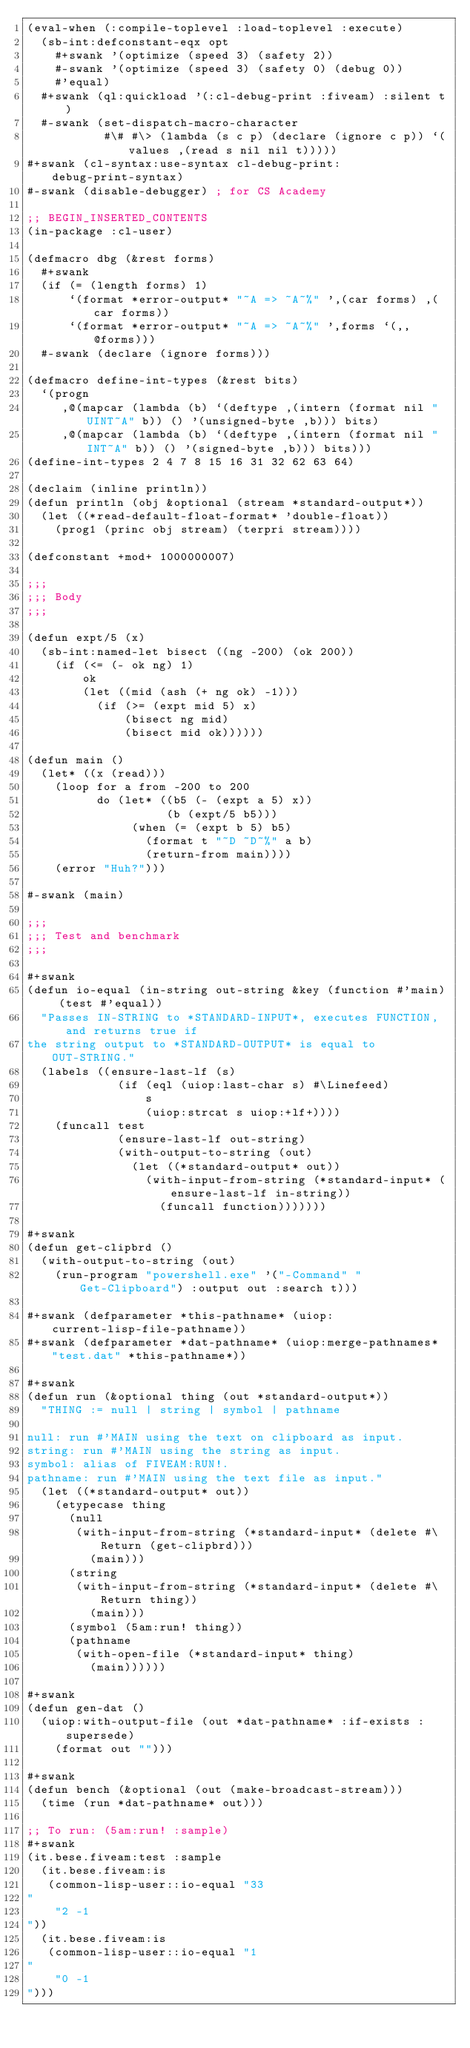<code> <loc_0><loc_0><loc_500><loc_500><_Lisp_>(eval-when (:compile-toplevel :load-toplevel :execute)
  (sb-int:defconstant-eqx opt
    #+swank '(optimize (speed 3) (safety 2))
    #-swank '(optimize (speed 3) (safety 0) (debug 0))
    #'equal)
  #+swank (ql:quickload '(:cl-debug-print :fiveam) :silent t)
  #-swank (set-dispatch-macro-character
           #\# #\> (lambda (s c p) (declare (ignore c p)) `(values ,(read s nil nil t)))))
#+swank (cl-syntax:use-syntax cl-debug-print:debug-print-syntax)
#-swank (disable-debugger) ; for CS Academy

;; BEGIN_INSERTED_CONTENTS
(in-package :cl-user)

(defmacro dbg (&rest forms)
  #+swank
  (if (= (length forms) 1)
      `(format *error-output* "~A => ~A~%" ',(car forms) ,(car forms))
      `(format *error-output* "~A => ~A~%" ',forms `(,,@forms)))
  #-swank (declare (ignore forms)))

(defmacro define-int-types (&rest bits)
  `(progn
     ,@(mapcar (lambda (b) `(deftype ,(intern (format nil "UINT~A" b)) () '(unsigned-byte ,b))) bits)
     ,@(mapcar (lambda (b) `(deftype ,(intern (format nil "INT~A" b)) () '(signed-byte ,b))) bits)))
(define-int-types 2 4 7 8 15 16 31 32 62 63 64)

(declaim (inline println))
(defun println (obj &optional (stream *standard-output*))
  (let ((*read-default-float-format* 'double-float))
    (prog1 (princ obj stream) (terpri stream))))

(defconstant +mod+ 1000000007)

;;;
;;; Body
;;;

(defun expt/5 (x)
  (sb-int:named-let bisect ((ng -200) (ok 200))
    (if (<= (- ok ng) 1)
        ok
        (let ((mid (ash (+ ng ok) -1)))
          (if (>= (expt mid 5) x)
              (bisect ng mid)
              (bisect mid ok))))))

(defun main ()
  (let* ((x (read)))
    (loop for a from -200 to 200
          do (let* ((b5 (- (expt a 5) x))
                    (b (expt/5 b5)))
               (when (= (expt b 5) b5)
                 (format t "~D ~D~%" a b)
                 (return-from main))))
    (error "Huh?")))

#-swank (main)

;;;
;;; Test and benchmark
;;;

#+swank
(defun io-equal (in-string out-string &key (function #'main) (test #'equal))
  "Passes IN-STRING to *STANDARD-INPUT*, executes FUNCTION, and returns true if
the string output to *STANDARD-OUTPUT* is equal to OUT-STRING."
  (labels ((ensure-last-lf (s)
             (if (eql (uiop:last-char s) #\Linefeed)
                 s
                 (uiop:strcat s uiop:+lf+))))
    (funcall test
             (ensure-last-lf out-string)
             (with-output-to-string (out)
               (let ((*standard-output* out))
                 (with-input-from-string (*standard-input* (ensure-last-lf in-string))
                   (funcall function)))))))

#+swank
(defun get-clipbrd ()
  (with-output-to-string (out)
    (run-program "powershell.exe" '("-Command" "Get-Clipboard") :output out :search t)))

#+swank (defparameter *this-pathname* (uiop:current-lisp-file-pathname))
#+swank (defparameter *dat-pathname* (uiop:merge-pathnames* "test.dat" *this-pathname*))

#+swank
(defun run (&optional thing (out *standard-output*))
  "THING := null | string | symbol | pathname

null: run #'MAIN using the text on clipboard as input.
string: run #'MAIN using the string as input.
symbol: alias of FIVEAM:RUN!.
pathname: run #'MAIN using the text file as input."
  (let ((*standard-output* out))
    (etypecase thing
      (null
       (with-input-from-string (*standard-input* (delete #\Return (get-clipbrd)))
         (main)))
      (string
       (with-input-from-string (*standard-input* (delete #\Return thing))
         (main)))
      (symbol (5am:run! thing))
      (pathname
       (with-open-file (*standard-input* thing)
         (main))))))

#+swank
(defun gen-dat ()
  (uiop:with-output-file (out *dat-pathname* :if-exists :supersede)
    (format out "")))

#+swank
(defun bench (&optional (out (make-broadcast-stream)))
  (time (run *dat-pathname* out)))

;; To run: (5am:run! :sample)
#+swank
(it.bese.fiveam:test :sample
  (it.bese.fiveam:is
   (common-lisp-user::io-equal "33
"
    "2 -1
"))
  (it.bese.fiveam:is
   (common-lisp-user::io-equal "1
"
    "0 -1
")))
</code> 